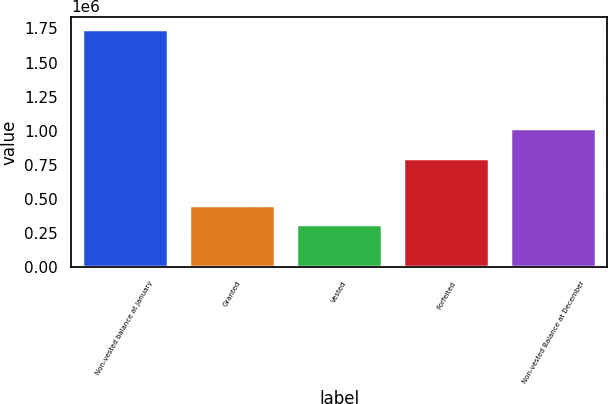Convert chart to OTSL. <chart><loc_0><loc_0><loc_500><loc_500><bar_chart><fcel>Non-vested balance at January<fcel>Granted<fcel>Vested<fcel>Forfeited<fcel>Non-vested Balance at December<nl><fcel>1.74906e+06<fcel>456876<fcel>313300<fcel>801221<fcel>1.02006e+06<nl></chart> 